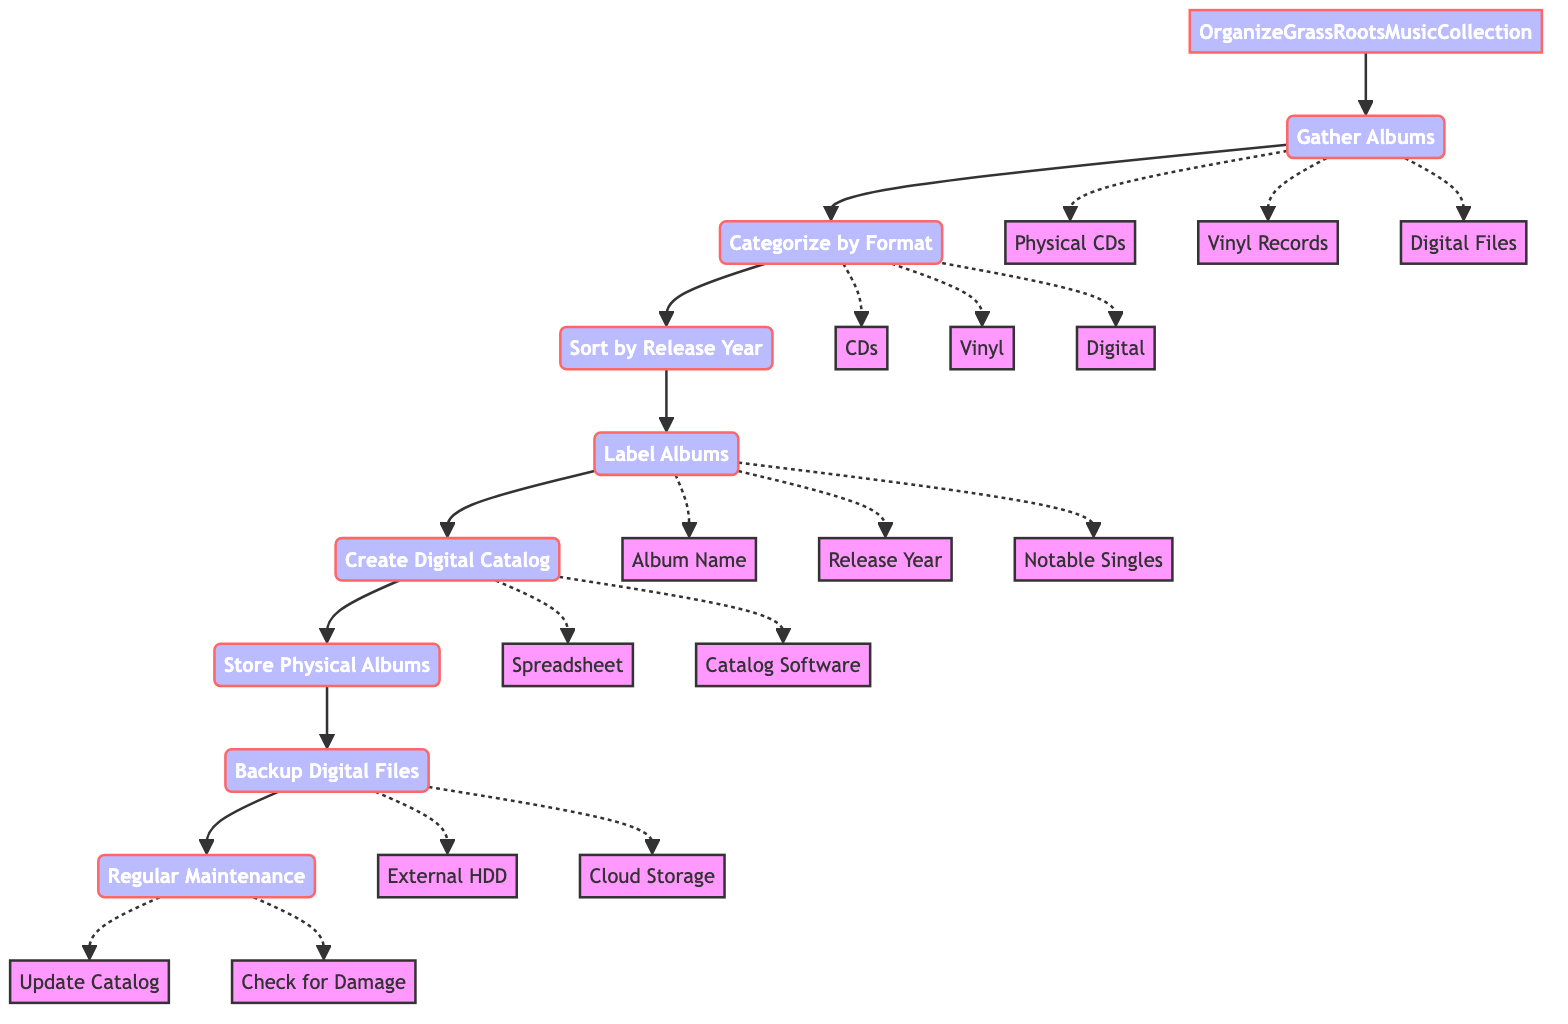What is the first step in organizing the music collection? The diagram shows that the first step is to gather all Grass Roots albums in one place for initial sorting.
Answer: Gather Albums How many nodes are there in this flowchart? By counting the main process steps listed in the flowchart, there are a total of 8 nodes representing each step in the organization process.
Answer: 8 What do you need to do after categorizing albums by format? According to the flowchart, the next step after categorizing is to sort albums by release year within each format category.
Answer: Sort by Release Year Which step includes labeling albums with essential details? The flowchart indicates that labeling albums with essential details is part of the fourth step.
Answer: Label Albums What should be included when creating a digital catalog? The diagram suggests that the catalog should include album details such as format type, release year, and condition for physical albums.
Answer: Format type, release year, condition What are the two main storage options for backing up digital files? Based on the visualization, the flowchart lists external hard drives and cloud storage as the two options for backing up digital files.
Answer: External HDD, Cloud Storage What is needed for regular maintenance of the collection? The diagram indicates that regular maintenance involves updating the catalog with new acquisitions and checking for any physical damage or digital file corruption.
Answer: Update Catalog, Check for Damage Which action is taken before creating a digital catalog? The flowchart indicates that labeling albums with essential details is the action that must be completed prior to creating a digital catalog.
Answer: Label Albums 